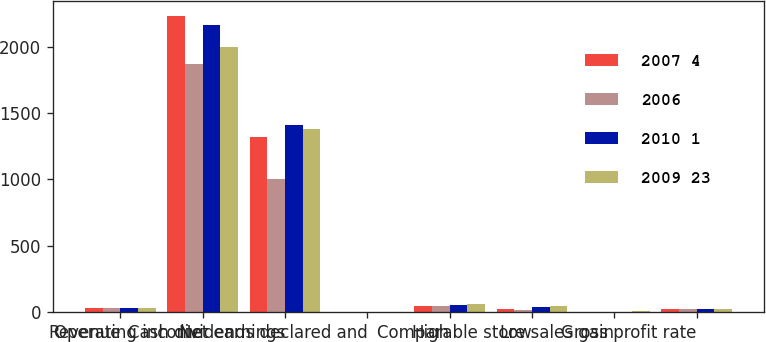<chart> <loc_0><loc_0><loc_500><loc_500><stacked_bar_chart><ecel><fcel>Revenue<fcel>Operating income<fcel>Net earnings<fcel>Cash dividends declared and<fcel>High<fcel>Low<fcel>Comparable store sales gain<fcel>Gross profit rate<nl><fcel>2007 4<fcel>33.175<fcel>2235<fcel>1317<fcel>0.56<fcel>45.55<fcel>23.97<fcel>0.6<fcel>24.5<nl><fcel>2006<fcel>33.175<fcel>1870<fcel>1003<fcel>0.54<fcel>48.03<fcel>16.42<fcel>1.3<fcel>24.4<nl><fcel>2010 1<fcel>33.175<fcel>2161<fcel>1407<fcel>0.46<fcel>53.9<fcel>41.85<fcel>2.9<fcel>23.9<nl><fcel>2009 23<fcel>33.175<fcel>1999<fcel>1377<fcel>0.36<fcel>59.5<fcel>43.51<fcel>5<fcel>24.4<nl></chart> 